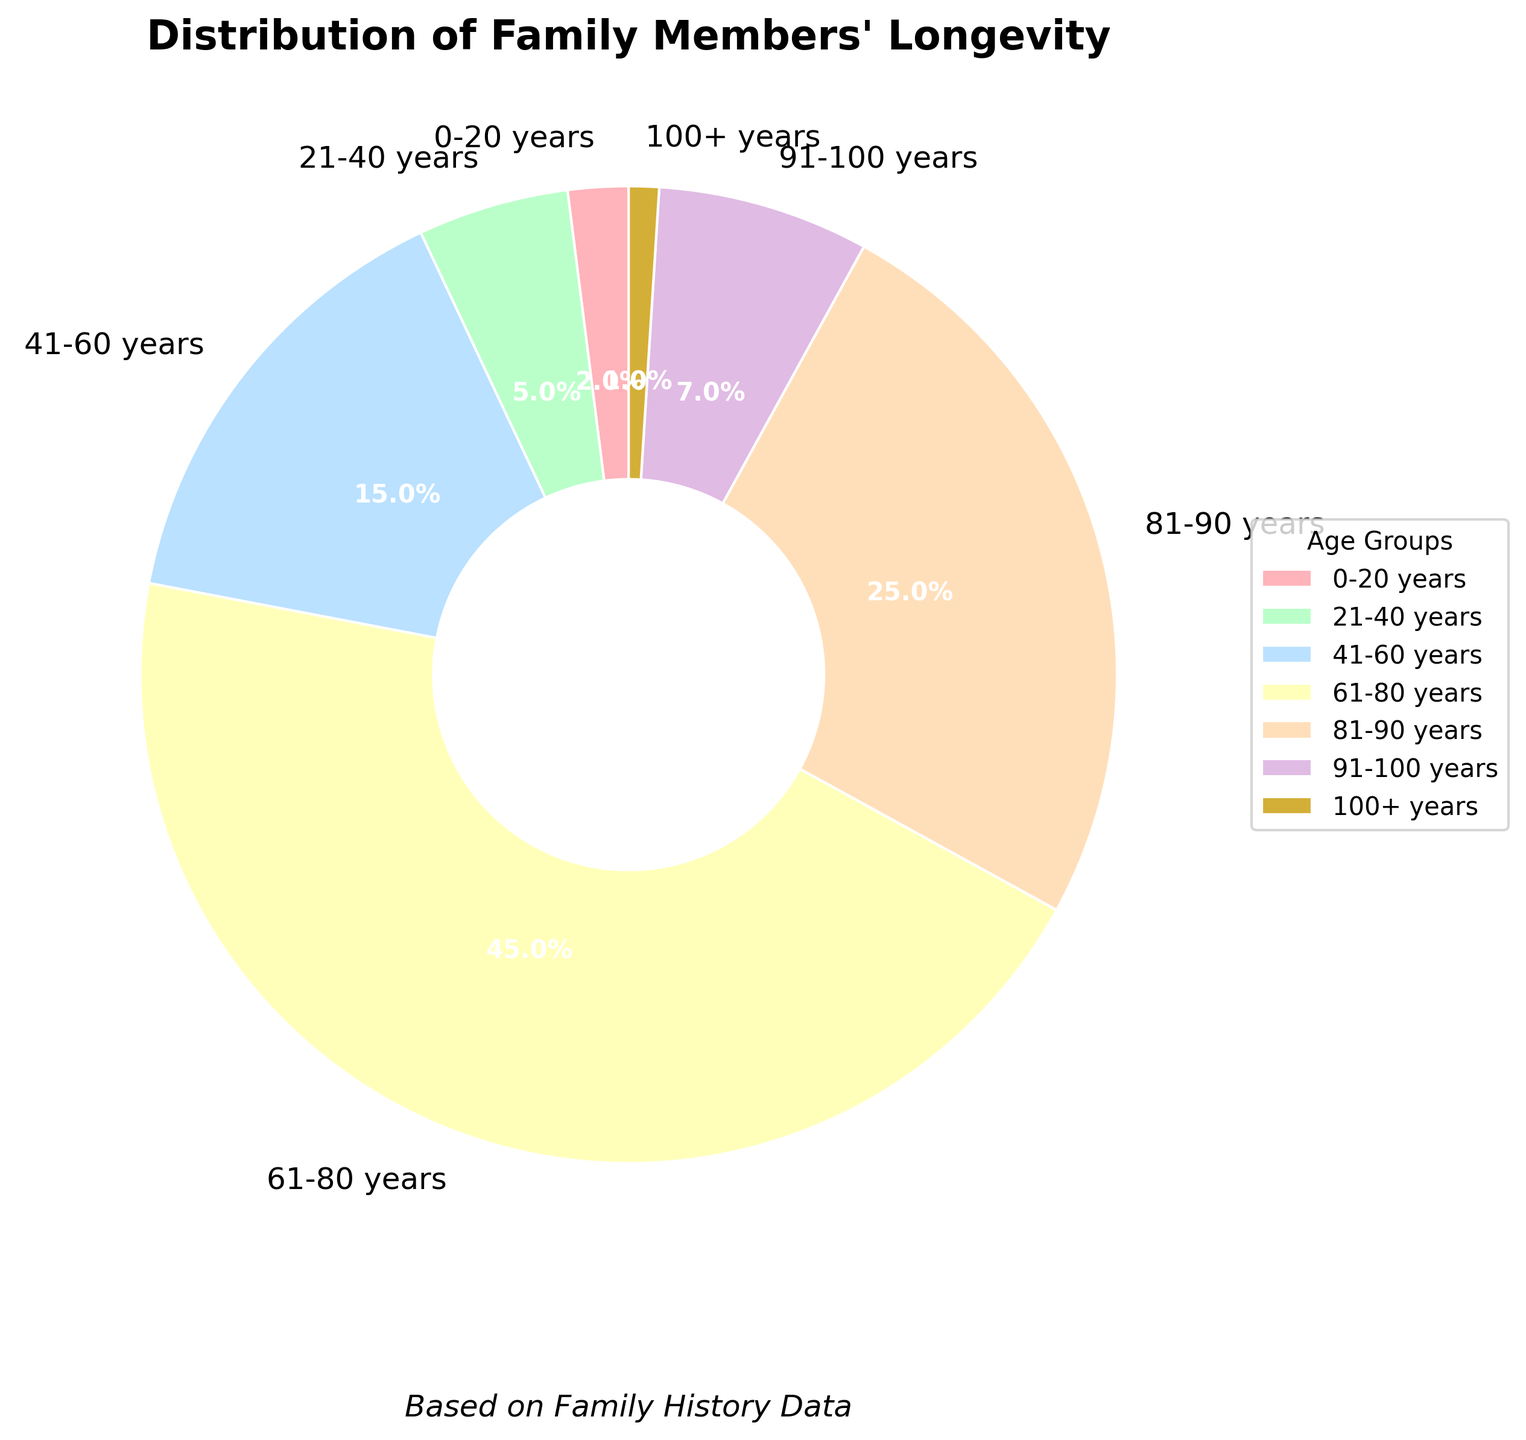What percentage of family members lived beyond 90 years? We need to add the percentages of the age groups `91-100 years` and `100+ years`. So, 7% (91-100 years) + 1% (100+ years) = 8%
Answer: 8% Which age group has the highest percentage of family members? By inspecting the pie chart, the largest wedge corresponds to `61-80 years`, which has a percentage of 45%
Answer: 61-80 years How does the percentage of family members who lived between 21-40 years compare to those between 41-60 years? The `21-40 years` group has 5% while the `41-60 years` group has 15%. Thus, `41-60 years` has 10% more
Answer: 10% more (41-60 years) What is the combined percentage of family members who lived up to 60 years? Add the percentages of the age groups `0-20 years`, `21-40 years`, and `41-60 years`. So, 2% (0-20 years) + 5% (21-40 years) + 15% (41-60 years) = 22%
Answer: 22% Which color corresponds to the 81-90 years age group in the pie chart? By looking at the colors, the `81-90 years` segment is represented by an orange-like color
Answer: Orange-like color What share of the family members is depicted in red color? The red color represents the `0-20 years` age group, which has a percentage of 2%
Answer: 2% Which two age groups have almost the same size wedges in the pie chart? The `91-100 years` group (7%) and the `21-40 years` group (5%) are the closest in size, with only a 2% difference
Answer: 91-100 years and 21-40 years Is the percentage of family members aged 61-80 years more than twice the percentage of those aged 81-90 years? The `61-80 years` group has 45%, and the `81-90 years` group has 25%. Since 45% > 2*25% (which is 50%), the answer is no
Answer: No What is the difference in percentage between the age groups `81-90 years` and `91-100 years`? Subtract the percentage of `91-100 years` from `81-90 years`. So, 25% - 7% = 18%
Answer: 18% What fraction of the family members lived between 61 and 100+ years? Add the percentages of the age groups `61-80 years`, `81-90 years`, `91-100 years`, and `100+ years`. So, 45% + 25% + 7% + 1% = 78%
Answer: 78% 